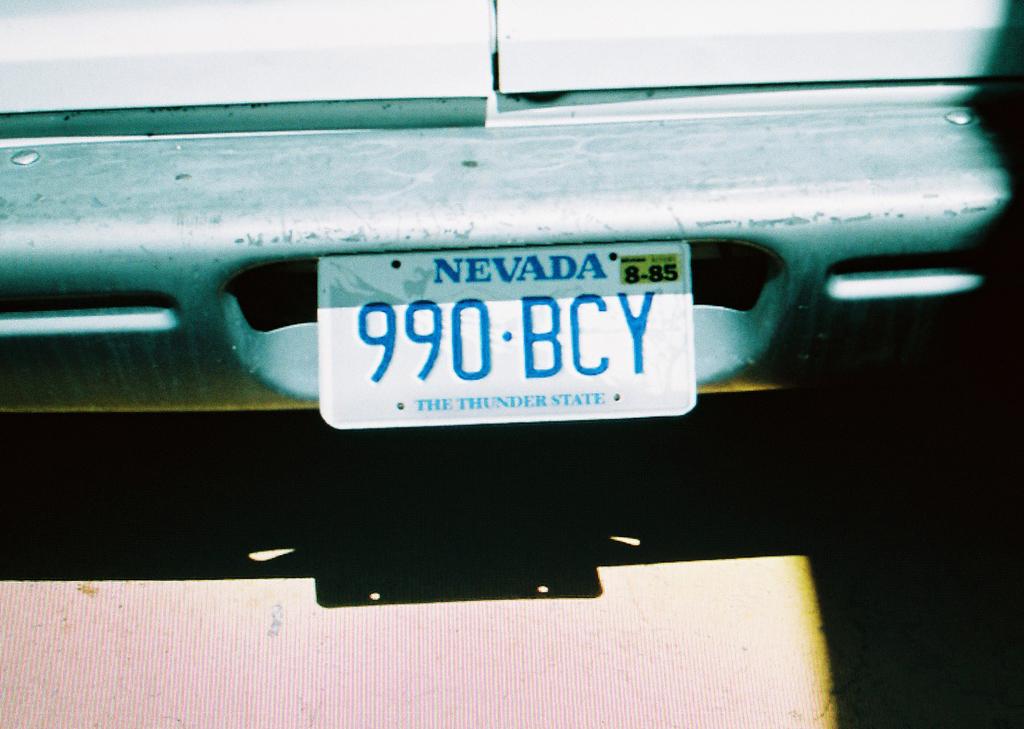What state is the license plate from?
Provide a short and direct response. Nevada. 